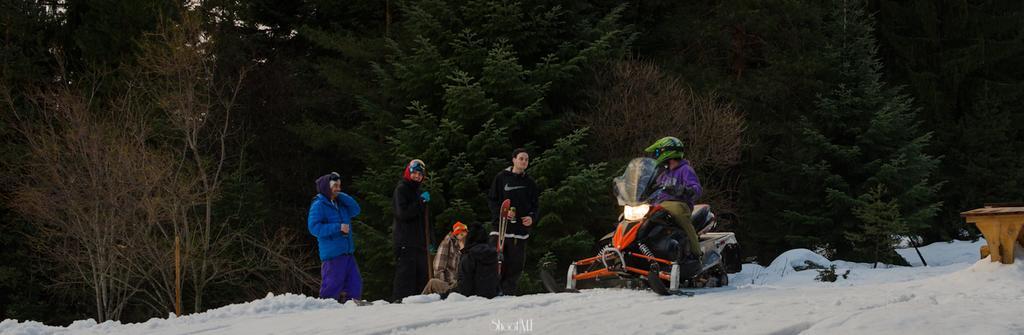Can you describe this image briefly? This is an outside view. At the bottom of the image I can see the snow. There are few people wearing jackets and standing. On the right side, I can see a person is sitting on a vehicle wearing jacket and helmet and looking at these people who are standing. In the background there are many trees. 